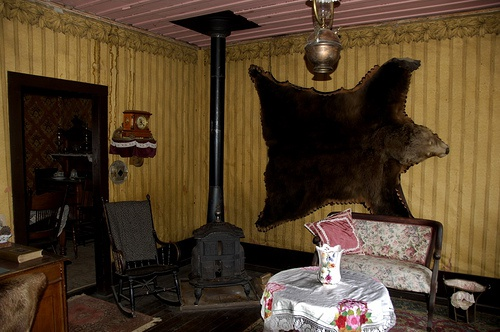Describe the objects in this image and their specific colors. I can see bear in maroon, black, and olive tones, couch in maroon, darkgray, black, and gray tones, chair in maroon, black, and gray tones, chair in maroon, black, and gray tones, and vase in maroon, white, darkgray, pink, and gray tones in this image. 